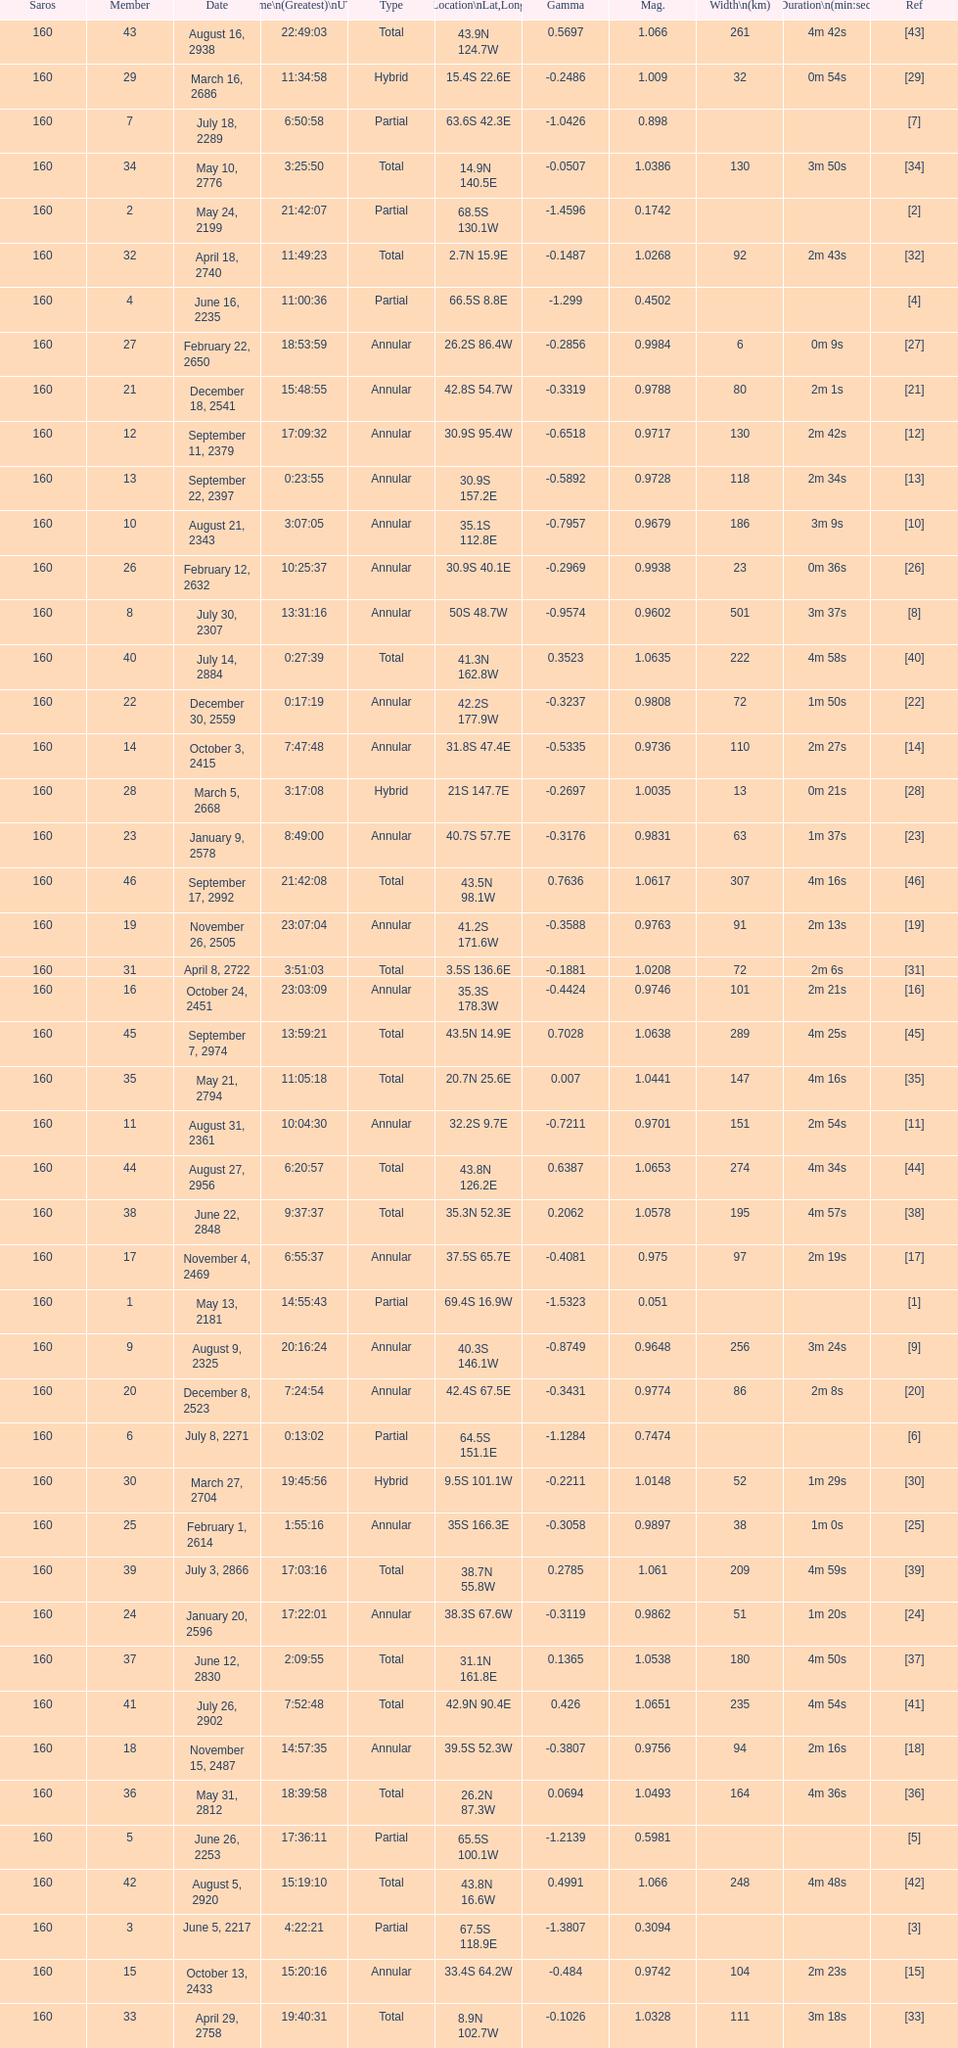How many solar saros events lasted longer than 4 minutes? 12. 